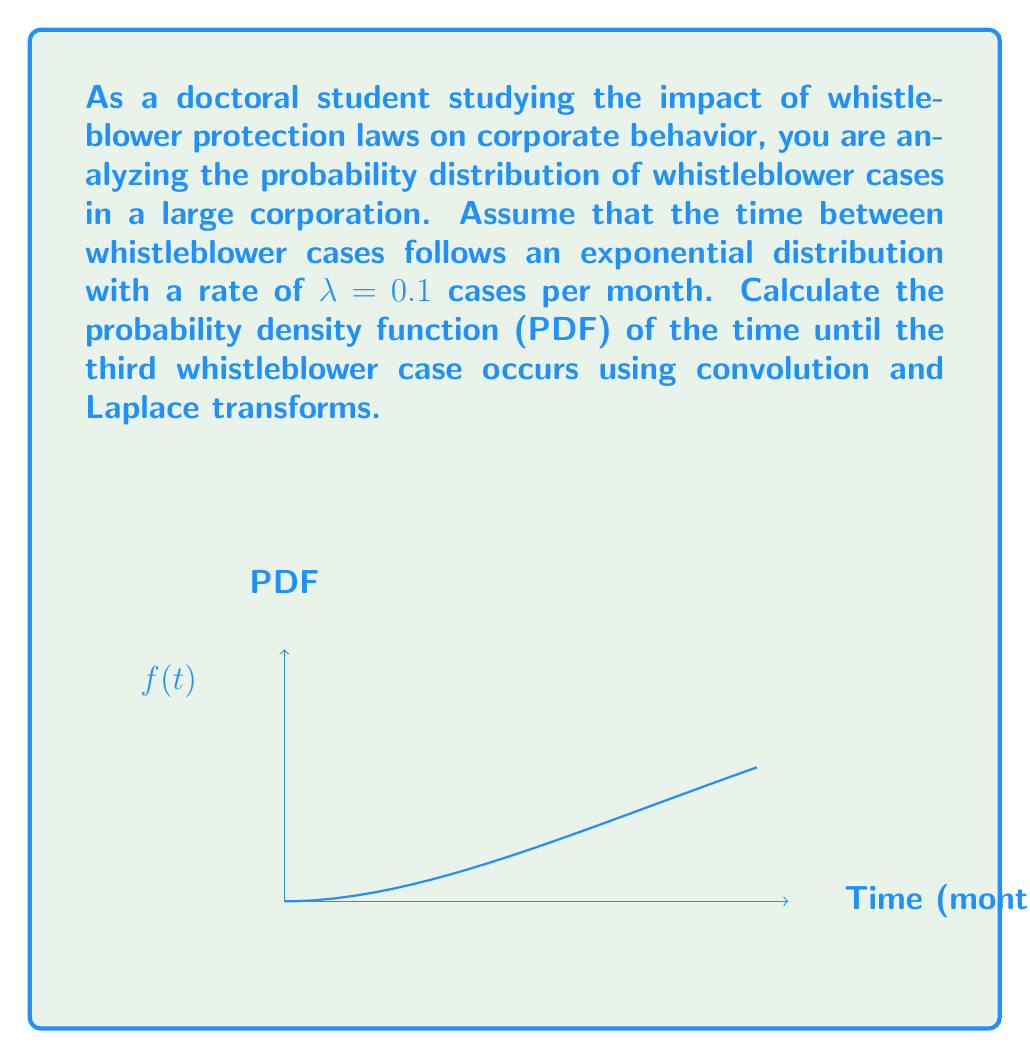Teach me how to tackle this problem. Let's approach this step-by-step:

1) The time between whistleblower cases follows an exponential distribution with rate λ = 0.1. The PDF of this distribution is:

   $$f_X(t) = λe^{-λt} = 0.1e^{-0.1t}$$

2) We need to find the distribution of the sum of three independent exponential random variables. This can be done using convolution, but it's easier to use Laplace transforms.

3) The Laplace transform of the exponential distribution is:

   $$F_X(s) = \frac{λ}{s + λ} = \frac{0.1}{s + 0.1}$$

4) For the sum of three independent random variables, we multiply their Laplace transforms:

   $$F_Y(s) = \left(\frac{0.1}{s + 0.1}\right)^3 = \frac{0.001}{(s + 0.1)^3}$$

5) To find the PDF, we need to take the inverse Laplace transform of F_Y(s). The inverse Laplace transform of $\frac{a^n}{(s+a)^n}$ is $\frac{t^{n-1}}{(n-1)!}e^{-at}$.

6) Therefore, the PDF of the time until the third whistleblower case is:

   $$f_Y(t) = \frac{0.001 \cdot t^2}{2!}e^{-0.1t} = 0.0005t^2e^{-0.1t}$$

This is an Erlang distribution with shape parameter k = 3 and rate parameter λ = 0.1.
Answer: $$f_Y(t) = 0.0005t^2e^{-0.1t}$$ 